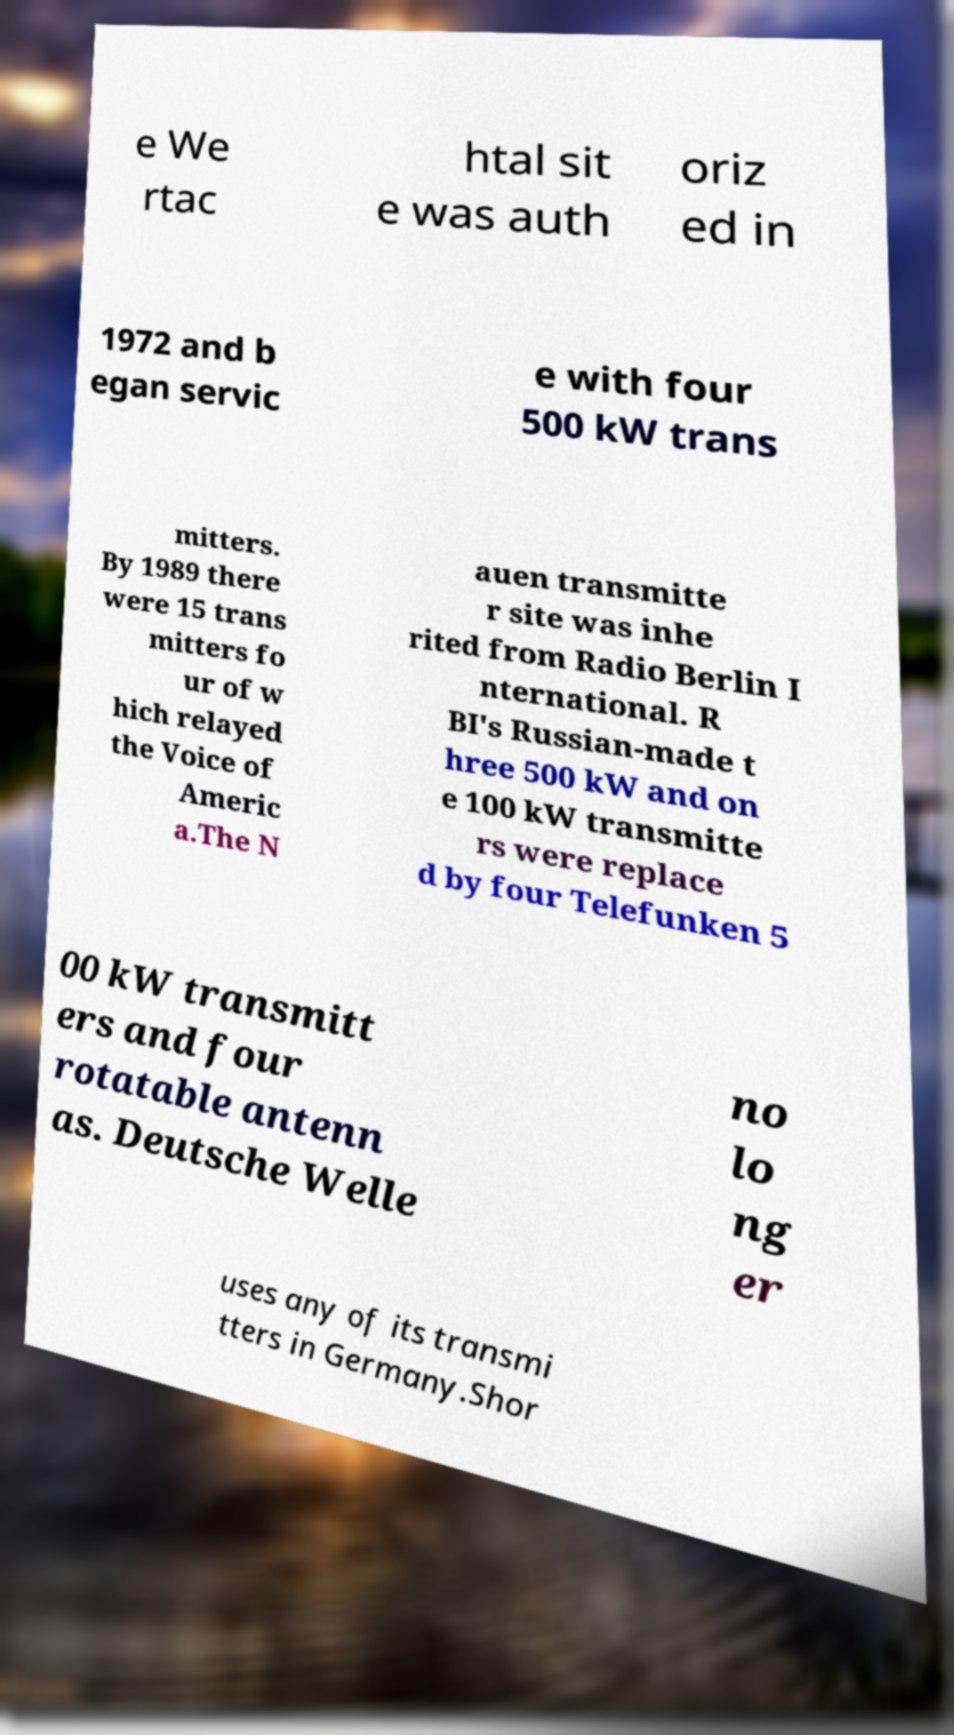Could you extract and type out the text from this image? e We rtac htal sit e was auth oriz ed in 1972 and b egan servic e with four 500 kW trans mitters. By 1989 there were 15 trans mitters fo ur of w hich relayed the Voice of Americ a.The N auen transmitte r site was inhe rited from Radio Berlin I nternational. R BI's Russian-made t hree 500 kW and on e 100 kW transmitte rs were replace d by four Telefunken 5 00 kW transmitt ers and four rotatable antenn as. Deutsche Welle no lo ng er uses any of its transmi tters in Germany.Shor 